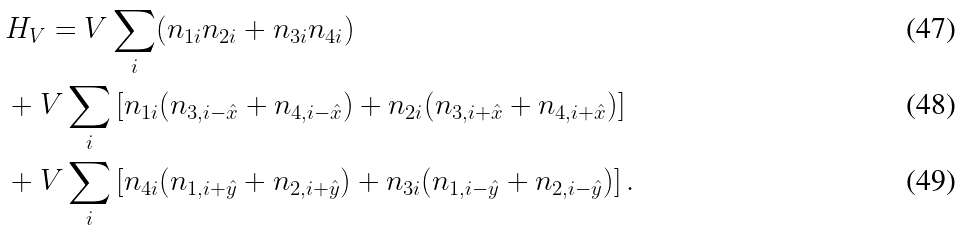Convert formula to latex. <formula><loc_0><loc_0><loc_500><loc_500>& H _ { V } = V \sum _ { i } ( n _ { 1 i } n _ { 2 i } + n _ { 3 i } n _ { 4 i } ) \\ & + V \sum _ { i } \left [ n _ { 1 i } ( n _ { 3 , i - \hat { x } } + n _ { 4 , i - \hat { x } } ) + n _ { 2 i } ( n _ { 3 , i + \hat { x } } + n _ { 4 , i + \hat { x } } ) \right ] \\ & + V \sum _ { i } \left [ n _ { 4 i } ( n _ { 1 , i + \hat { y } } + n _ { 2 , i + \hat { y } } ) + n _ { 3 i } ( n _ { 1 , i - \hat { y } } + n _ { 2 , i - \hat { y } } ) \right ] .</formula> 